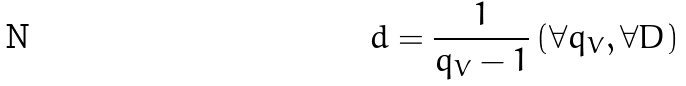<formula> <loc_0><loc_0><loc_500><loc_500>d = \frac { 1 } { q _ { V } - 1 } \, ( \forall q _ { V } , \forall D )</formula> 